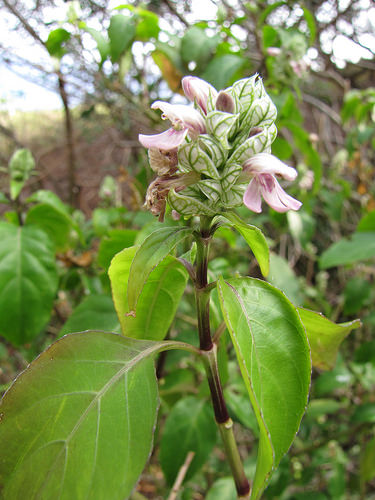<image>
Is there a flower behind the plant? No. The flower is not behind the plant. From this viewpoint, the flower appears to be positioned elsewhere in the scene. 